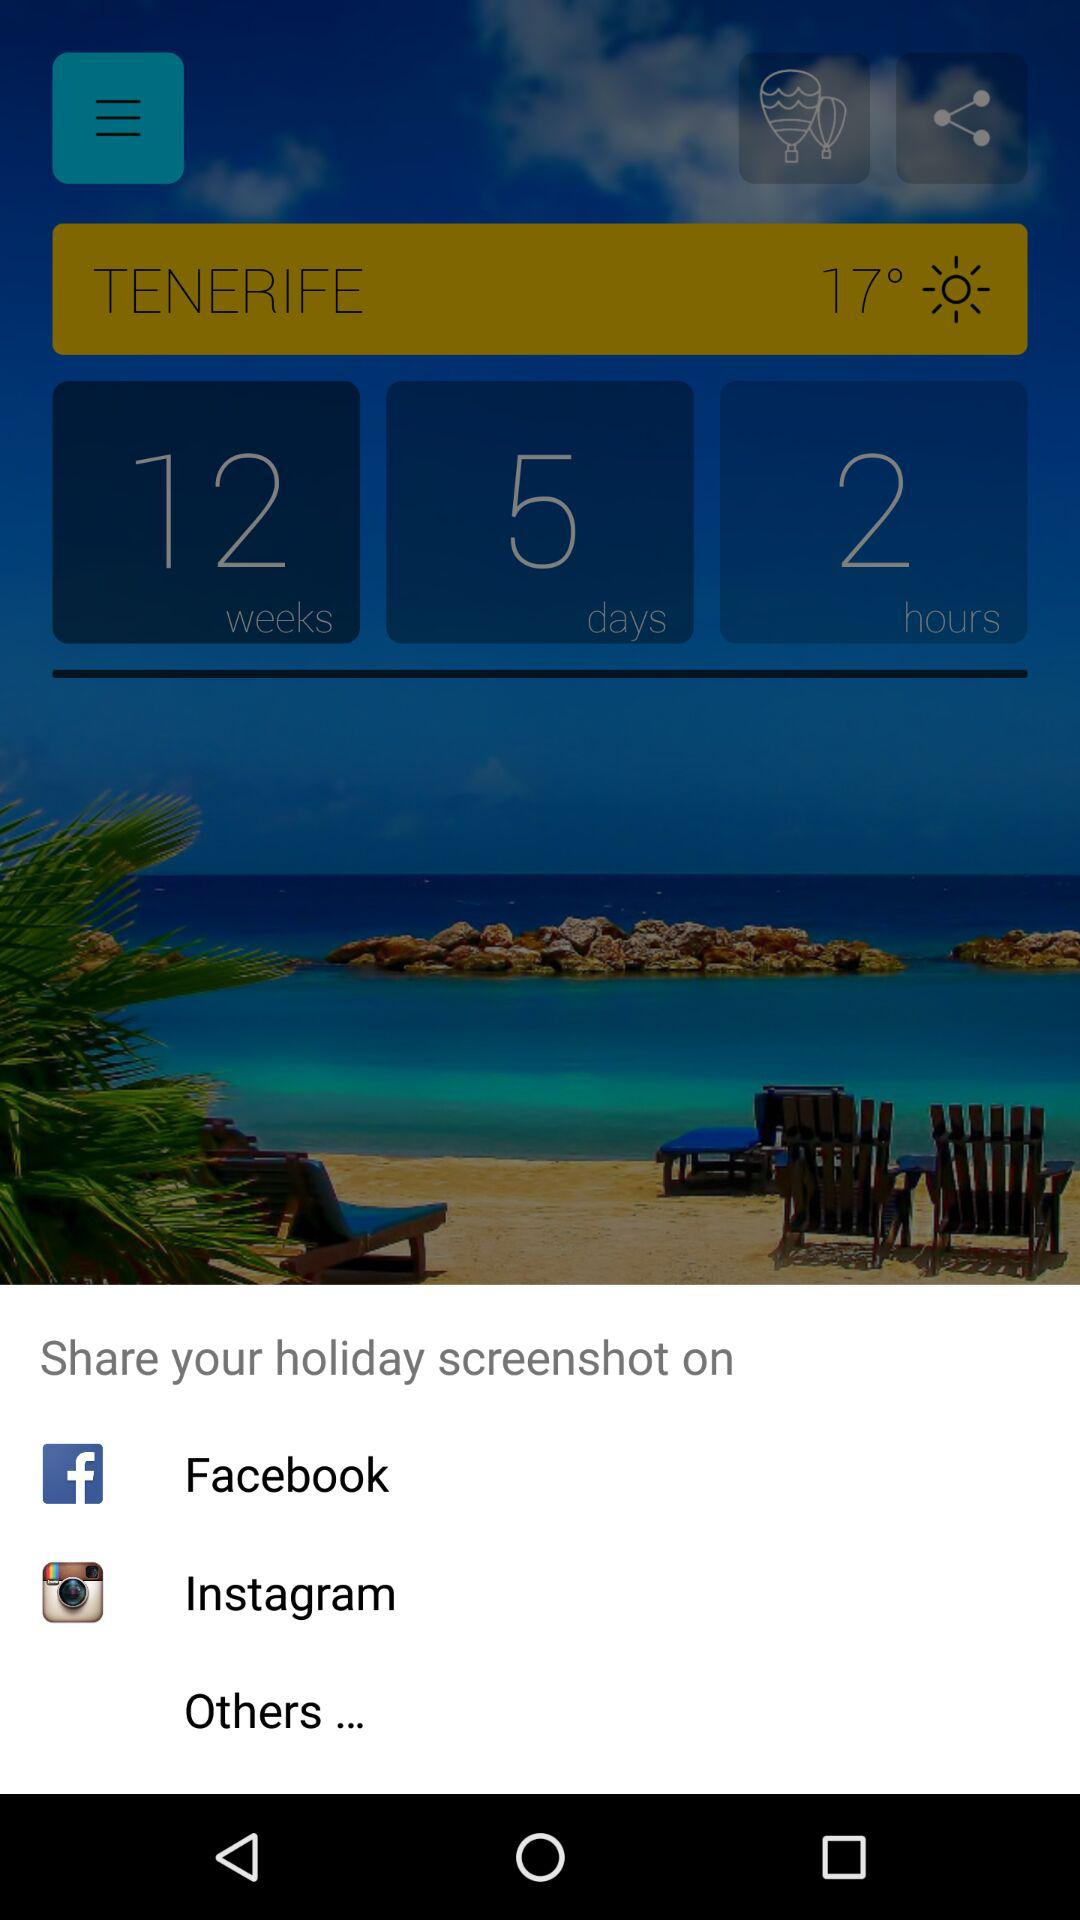What is the temperature? The temperature is 17°. 